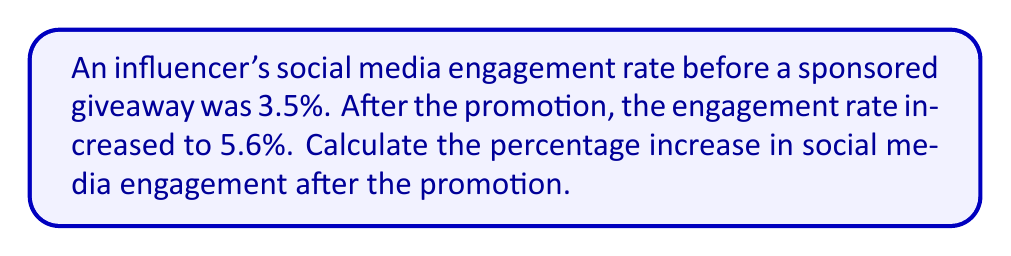Solve this math problem. To calculate the percentage increase in social media engagement, we need to follow these steps:

1. Calculate the absolute increase in engagement rate:
   $\text{Increase} = \text{New rate} - \text{Original rate}$
   $\text{Increase} = 5.6\% - 3.5\% = 2.1\%$

2. Calculate the percentage increase using the formula:
   $$\text{Percentage increase} = \frac{\text{Increase}}{\text{Original rate}} \times 100\%$$

3. Substitute the values:
   $$\text{Percentage increase} = \frac{2.1\%}{3.5\%} \times 100\%$$

4. Simplify the fraction:
   $$\text{Percentage increase} = \frac{2.1}{3.5} \times 100\%$$

5. Perform the division:
   $$\text{Percentage increase} = 0.6 \times 100\% = 60\%$$

Therefore, the percentage increase in social media engagement after the promotion is 60%.
Answer: 60% 